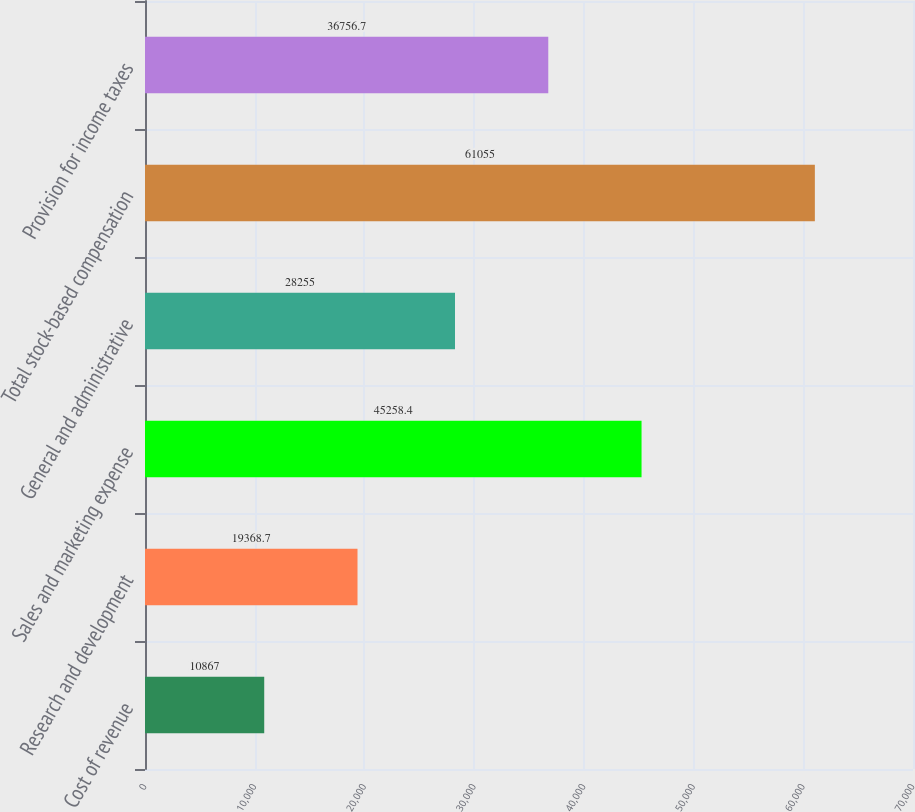<chart> <loc_0><loc_0><loc_500><loc_500><bar_chart><fcel>Cost of revenue<fcel>Research and development<fcel>Sales and marketing expense<fcel>General and administrative<fcel>Total stock-based compensation<fcel>Provision for income taxes<nl><fcel>10867<fcel>19368.7<fcel>45258.4<fcel>28255<fcel>61055<fcel>36756.7<nl></chart> 